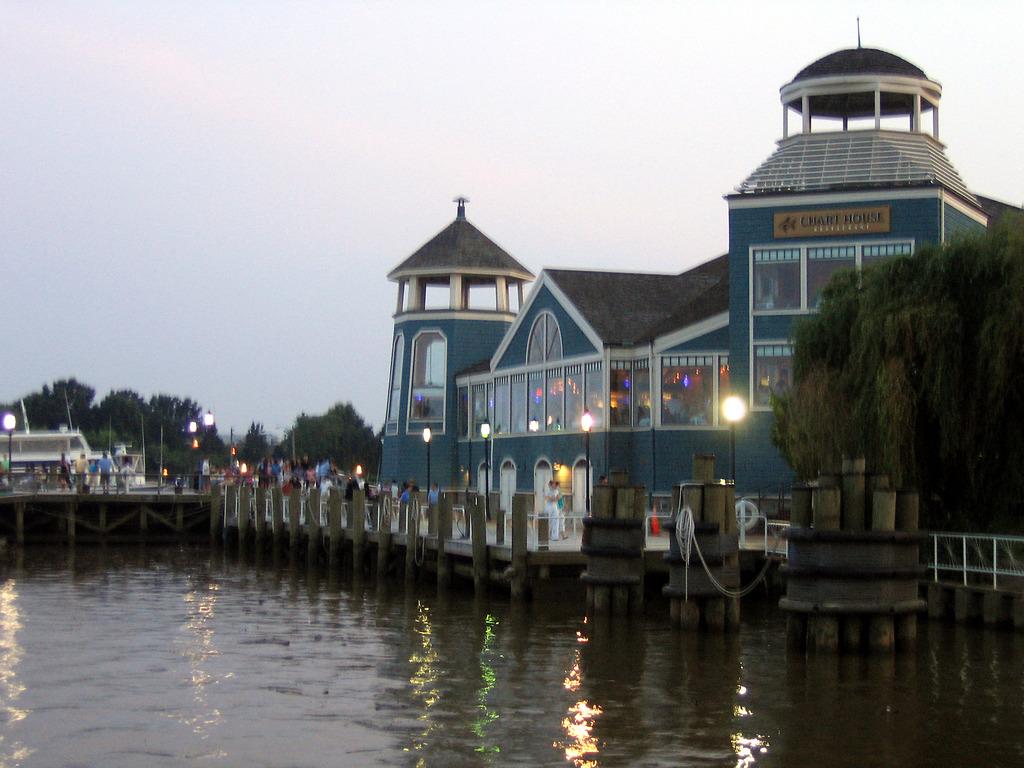What is the name of this restaurant?
Your answer should be very brief. Chart house. 